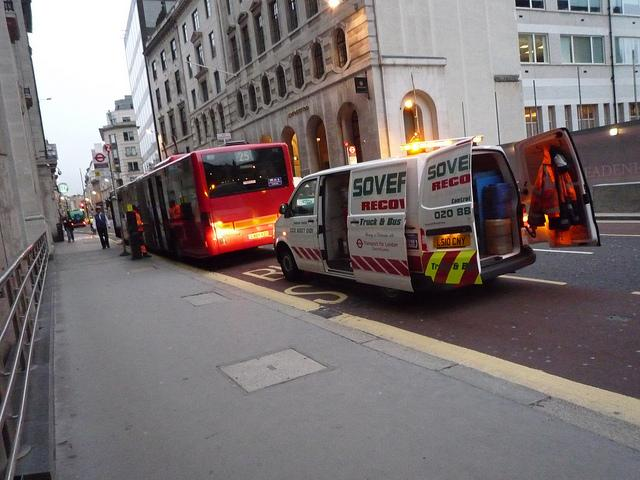Why is the red vehicle stopped here? board passengers 